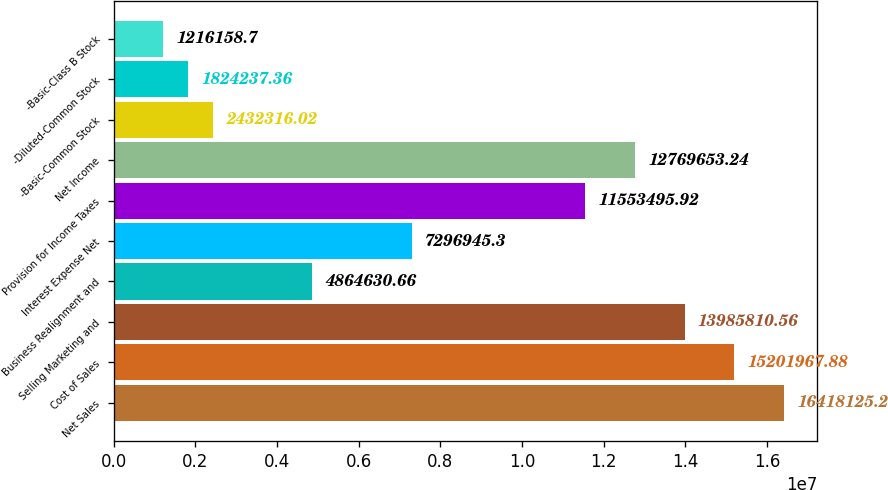<chart> <loc_0><loc_0><loc_500><loc_500><bar_chart><fcel>Net Sales<fcel>Cost of Sales<fcel>Selling Marketing and<fcel>Business Realignment and<fcel>Interest Expense Net<fcel>Provision for Income Taxes<fcel>Net Income<fcel>-Basic-Common Stock<fcel>-Diluted-Common Stock<fcel>-Basic-Class B Stock<nl><fcel>1.64181e+07<fcel>1.5202e+07<fcel>1.39858e+07<fcel>4.86463e+06<fcel>7.29695e+06<fcel>1.15535e+07<fcel>1.27697e+07<fcel>2.43232e+06<fcel>1.82424e+06<fcel>1.21616e+06<nl></chart> 